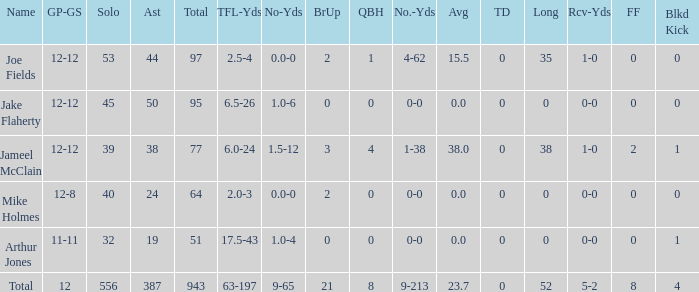How many tackle assists does the player with an average of 23.7 possess? 387.0. 